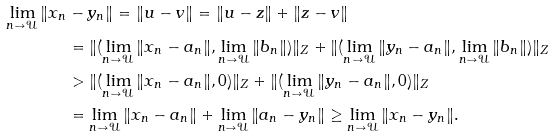Convert formula to latex. <formula><loc_0><loc_0><loc_500><loc_500>\lim _ { n \to \mathcal { U } } \| x _ { n } & - y _ { n } \| = \| u - v \| = \| u - z \| + \| z - v \| \\ & = \| ( \lim _ { n \to \mathcal { U } } \| x _ { n } - a _ { n } \| , \lim _ { n \to \mathcal { U } } \| b _ { n } \| ) \| _ { Z } + \| ( \lim _ { n \to \mathcal { U } } \| y _ { n } - a _ { n } \| , \lim _ { n \to \mathcal { U } } \| b _ { n } \| ) \| _ { Z } \\ & > \| ( \lim _ { n \to \mathcal { U } } \| x _ { n } - a _ { n } \| , 0 ) \| _ { Z } + \| ( \lim _ { n \to \mathcal { U } } \| y _ { n } - a _ { n } \| , 0 ) \| _ { Z } \\ & = \lim _ { n \to \mathcal { U } } \| x _ { n } - a _ { n } \| + \lim _ { n \to \mathcal { U } } \| a _ { n } - y _ { n } \| \geq \lim _ { n \to \mathcal { U } } \| x _ { n } - y _ { n } \| .</formula> 